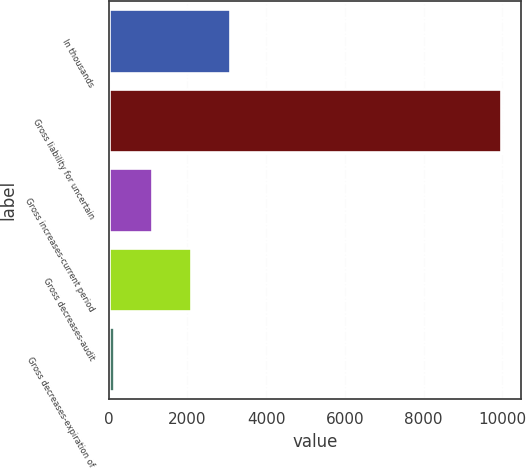Convert chart to OTSL. <chart><loc_0><loc_0><loc_500><loc_500><bar_chart><fcel>In thousands<fcel>Gross liability for uncertain<fcel>Gross increases-current period<fcel>Gross decreases-audit<fcel>Gross decreases-expiration of<nl><fcel>3079.7<fcel>9974<fcel>1107.9<fcel>2093.8<fcel>122<nl></chart> 